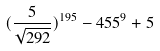<formula> <loc_0><loc_0><loc_500><loc_500>( \frac { 5 } { \sqrt { 2 9 2 } } ) ^ { 1 9 5 } - 4 5 5 ^ { 9 } + 5</formula> 